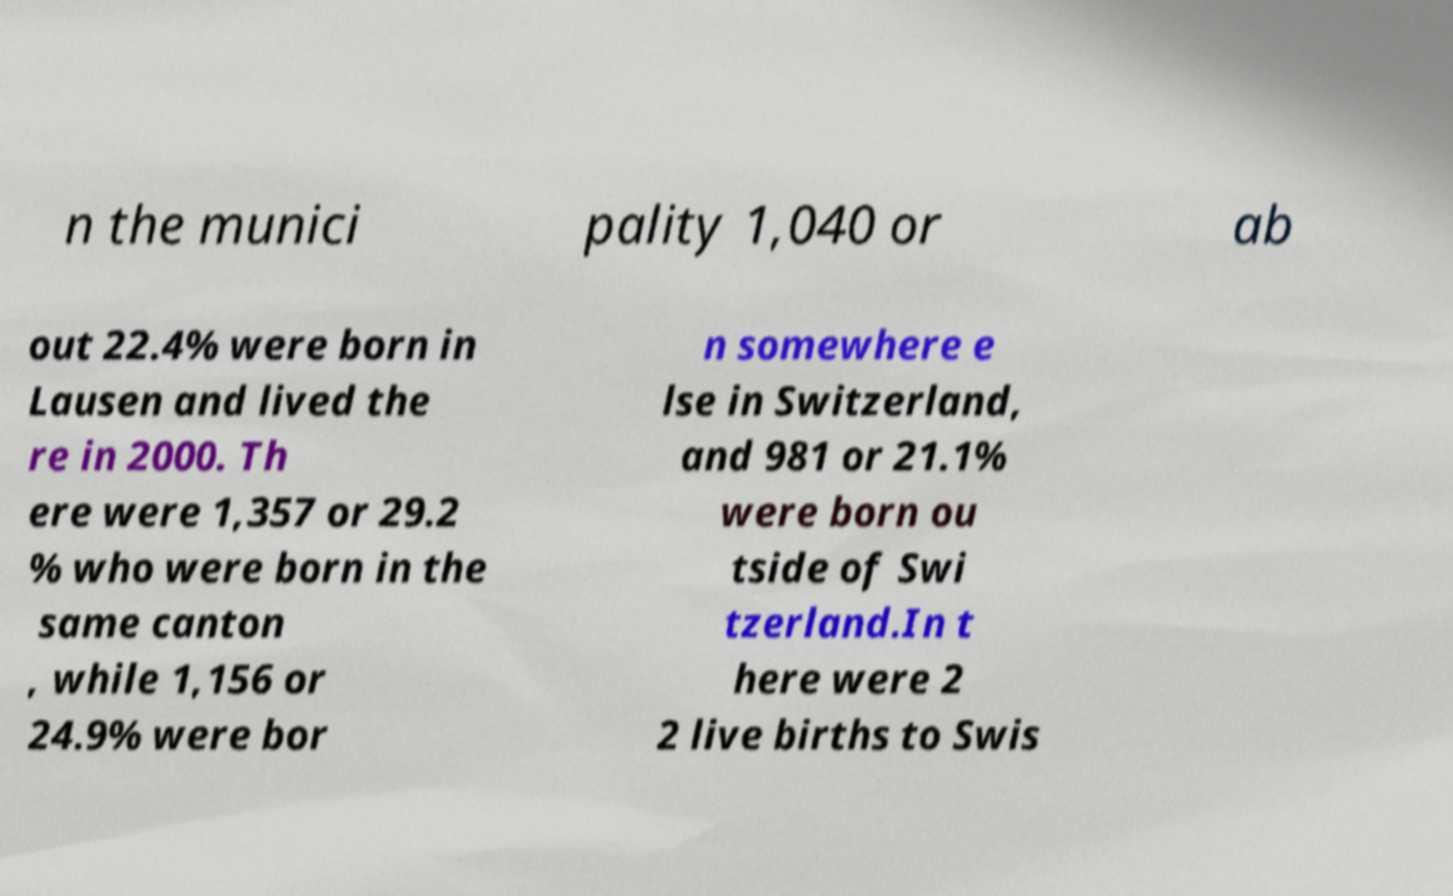Could you extract and type out the text from this image? n the munici pality 1,040 or ab out 22.4% were born in Lausen and lived the re in 2000. Th ere were 1,357 or 29.2 % who were born in the same canton , while 1,156 or 24.9% were bor n somewhere e lse in Switzerland, and 981 or 21.1% were born ou tside of Swi tzerland.In t here were 2 2 live births to Swis 